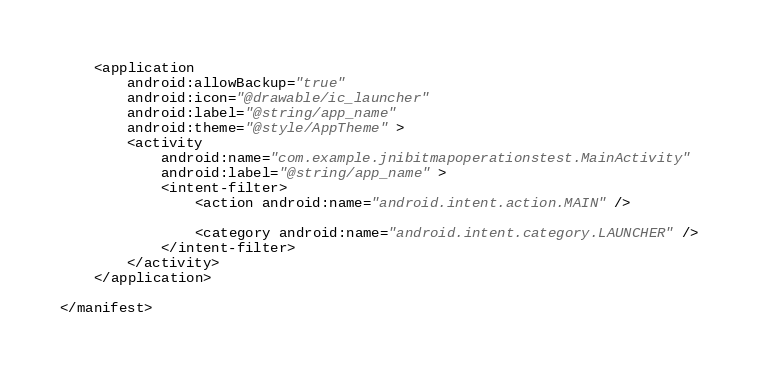Convert code to text. <code><loc_0><loc_0><loc_500><loc_500><_XML_>
    <application
        android:allowBackup="true"
        android:icon="@drawable/ic_launcher"
        android:label="@string/app_name"
        android:theme="@style/AppTheme" >
        <activity
            android:name="com.example.jnibitmapoperationstest.MainActivity"
            android:label="@string/app_name" >
            <intent-filter>
                <action android:name="android.intent.action.MAIN" />

                <category android:name="android.intent.category.LAUNCHER" />
            </intent-filter>
        </activity>
    </application>

</manifest>
</code> 